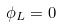Convert formula to latex. <formula><loc_0><loc_0><loc_500><loc_500>\phi _ { L } = 0</formula> 